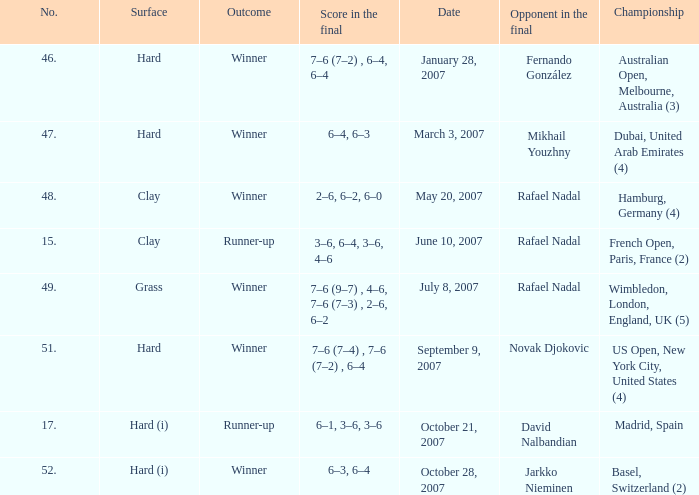Where is the championship where 6–1, 3–6, 3–6 is the score in the final? Madrid, Spain. 